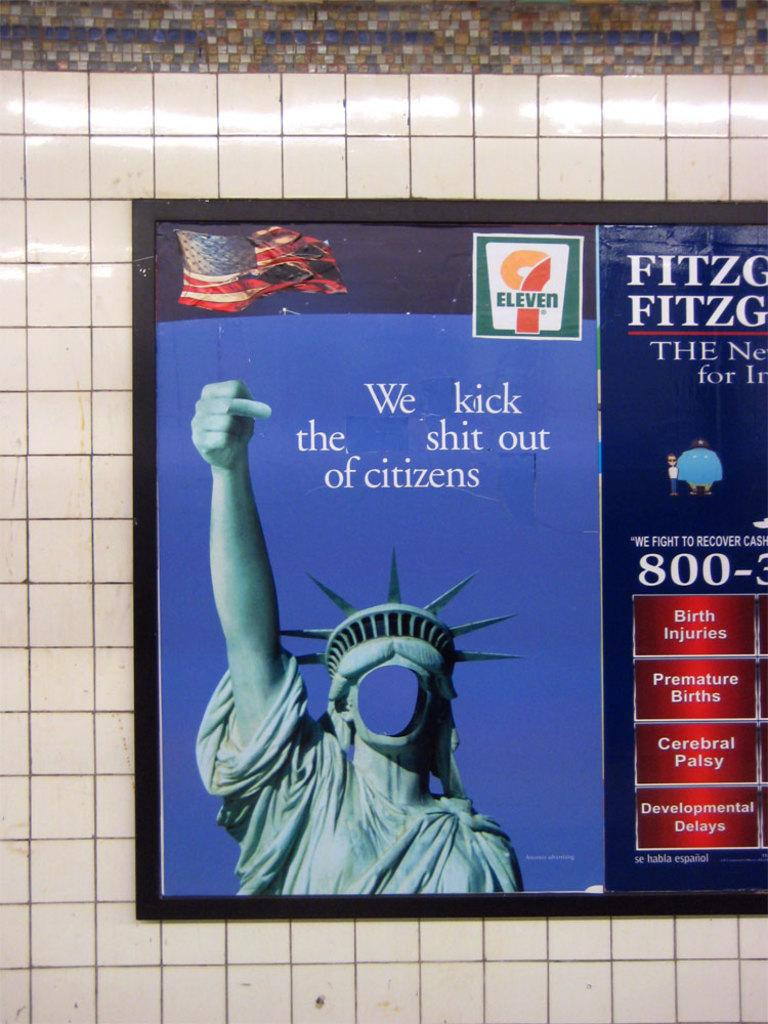Provide a one-sentence caption for the provided image. A faceless Statute of Liberty is giving the finger next to a brochure about birth injuries. 